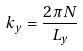<formula> <loc_0><loc_0><loc_500><loc_500>k _ { y } = \frac { 2 \pi N } { L _ { y } }</formula> 